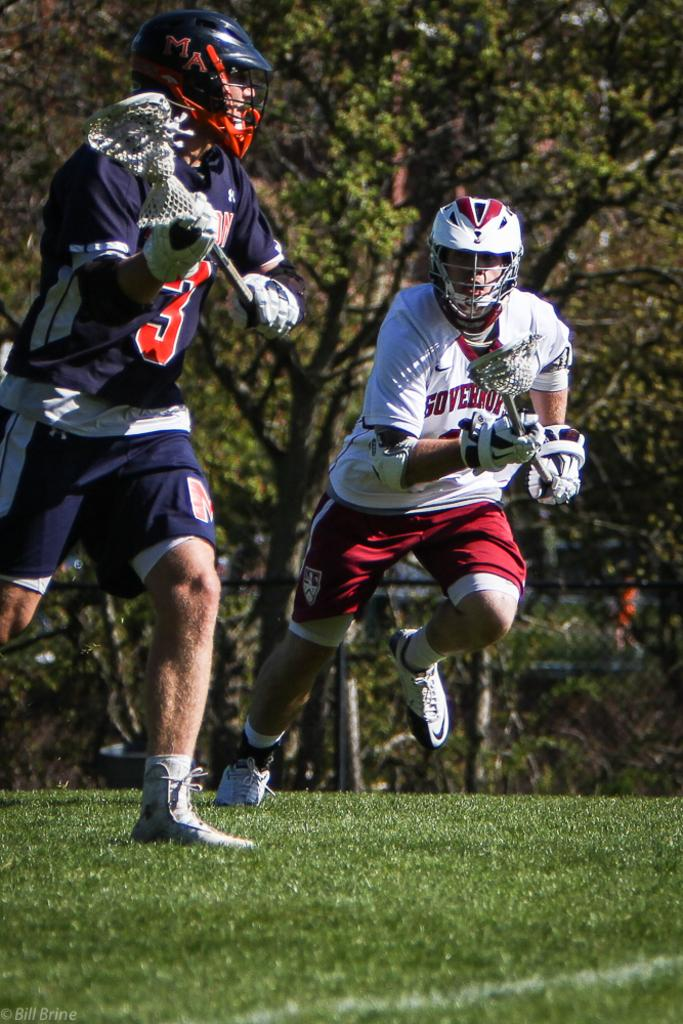How many players are in the image? There are two players in the image. What protective gear are the players wearing? The players are wearing helmets. What equipment are the players holding? The players are holding bats. Where are the players playing? The players are playing on a ground. What can be seen in the background of the image? There are trees in the background of the image. What type of soda is being advertised by the company in the image? There is no company or soda present in the image; it features two players playing a sport with bats and helmets. 